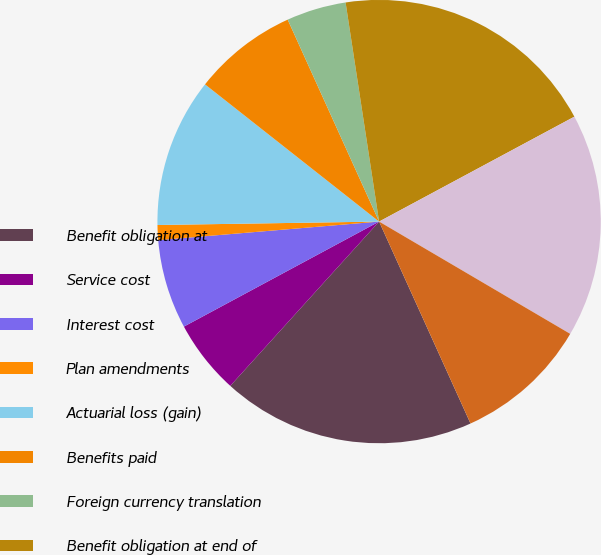Convert chart. <chart><loc_0><loc_0><loc_500><loc_500><pie_chart><fcel>Benefit obligation at<fcel>Service cost<fcel>Interest cost<fcel>Plan amendments<fcel>Actuarial loss (gain)<fcel>Benefits paid<fcel>Foreign currency translation<fcel>Benefit obligation at end of<fcel>Fair value of plan assets at<fcel>Actual gain on plan assets<nl><fcel>18.48%<fcel>5.43%<fcel>6.52%<fcel>1.09%<fcel>10.87%<fcel>7.61%<fcel>4.35%<fcel>19.57%<fcel>16.3%<fcel>9.78%<nl></chart> 